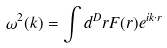<formula> <loc_0><loc_0><loc_500><loc_500>\omega ^ { 2 } ( k ) = \int d ^ { D } r F ( r ) e ^ { i k \cdot r }</formula> 